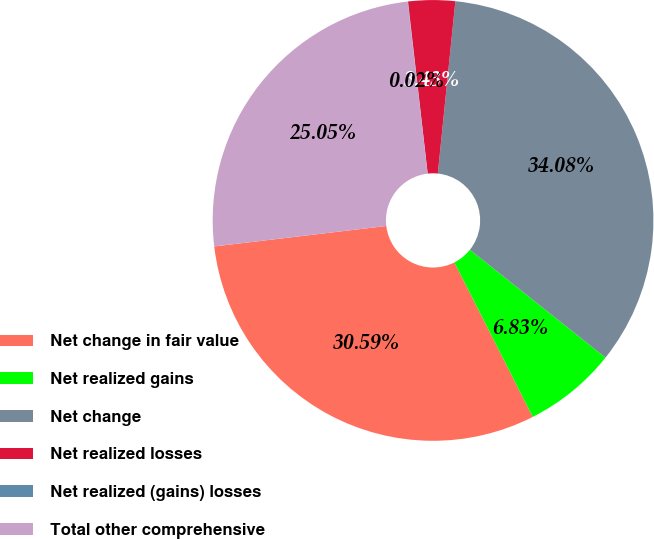<chart> <loc_0><loc_0><loc_500><loc_500><pie_chart><fcel>Net change in fair value<fcel>Net realized gains<fcel>Net change<fcel>Net realized losses<fcel>Net realized (gains) losses<fcel>Total other comprehensive<nl><fcel>30.59%<fcel>6.83%<fcel>34.08%<fcel>3.43%<fcel>0.02%<fcel>25.05%<nl></chart> 